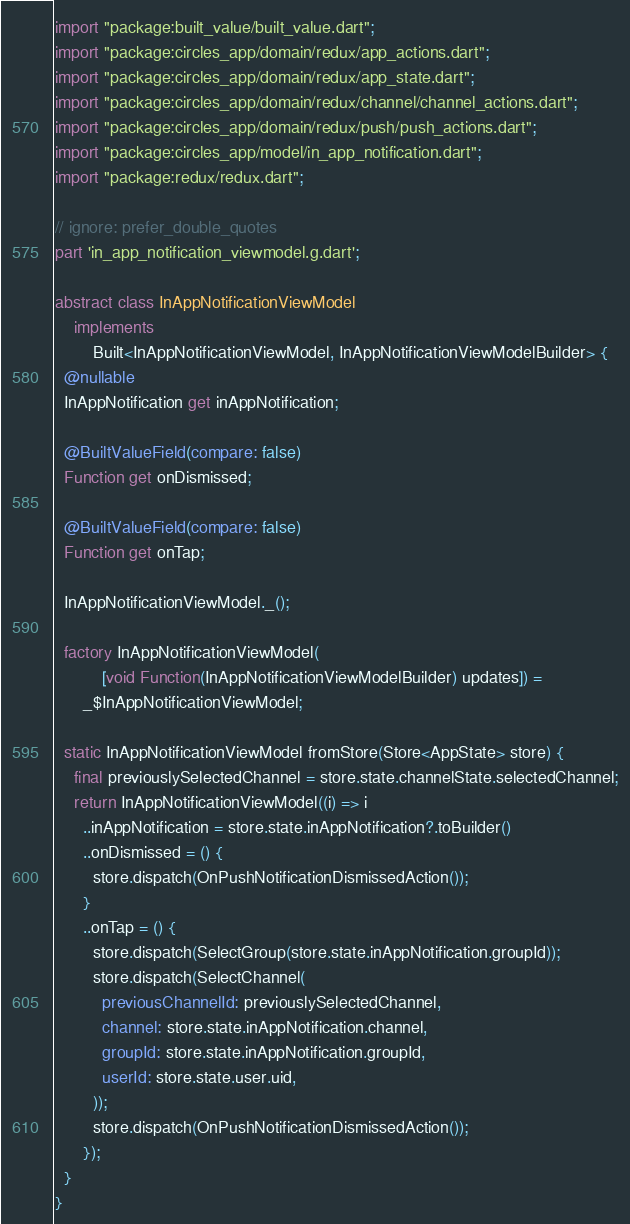<code> <loc_0><loc_0><loc_500><loc_500><_Dart_>import "package:built_value/built_value.dart";
import "package:circles_app/domain/redux/app_actions.dart";
import "package:circles_app/domain/redux/app_state.dart";
import "package:circles_app/domain/redux/channel/channel_actions.dart";
import "package:circles_app/domain/redux/push/push_actions.dart";
import "package:circles_app/model/in_app_notification.dart";
import "package:redux/redux.dart";

// ignore: prefer_double_quotes
part 'in_app_notification_viewmodel.g.dart';

abstract class InAppNotificationViewModel
    implements
        Built<InAppNotificationViewModel, InAppNotificationViewModelBuilder> {
  @nullable
  InAppNotification get inAppNotification;

  @BuiltValueField(compare: false)
  Function get onDismissed;

  @BuiltValueField(compare: false)
  Function get onTap;

  InAppNotificationViewModel._();

  factory InAppNotificationViewModel(
          [void Function(InAppNotificationViewModelBuilder) updates]) =
      _$InAppNotificationViewModel;

  static InAppNotificationViewModel fromStore(Store<AppState> store) {
    final previouslySelectedChannel = store.state.channelState.selectedChannel;
    return InAppNotificationViewModel((i) => i
      ..inAppNotification = store.state.inAppNotification?.toBuilder()
      ..onDismissed = () {
        store.dispatch(OnPushNotificationDismissedAction());
      }
      ..onTap = () {
        store.dispatch(SelectGroup(store.state.inAppNotification.groupId));
        store.dispatch(SelectChannel(
          previousChannelId: previouslySelectedChannel,
          channel: store.state.inAppNotification.channel,
          groupId: store.state.inAppNotification.groupId,
          userId: store.state.user.uid,
        ));
        store.dispatch(OnPushNotificationDismissedAction());
      });
  }
}
</code> 